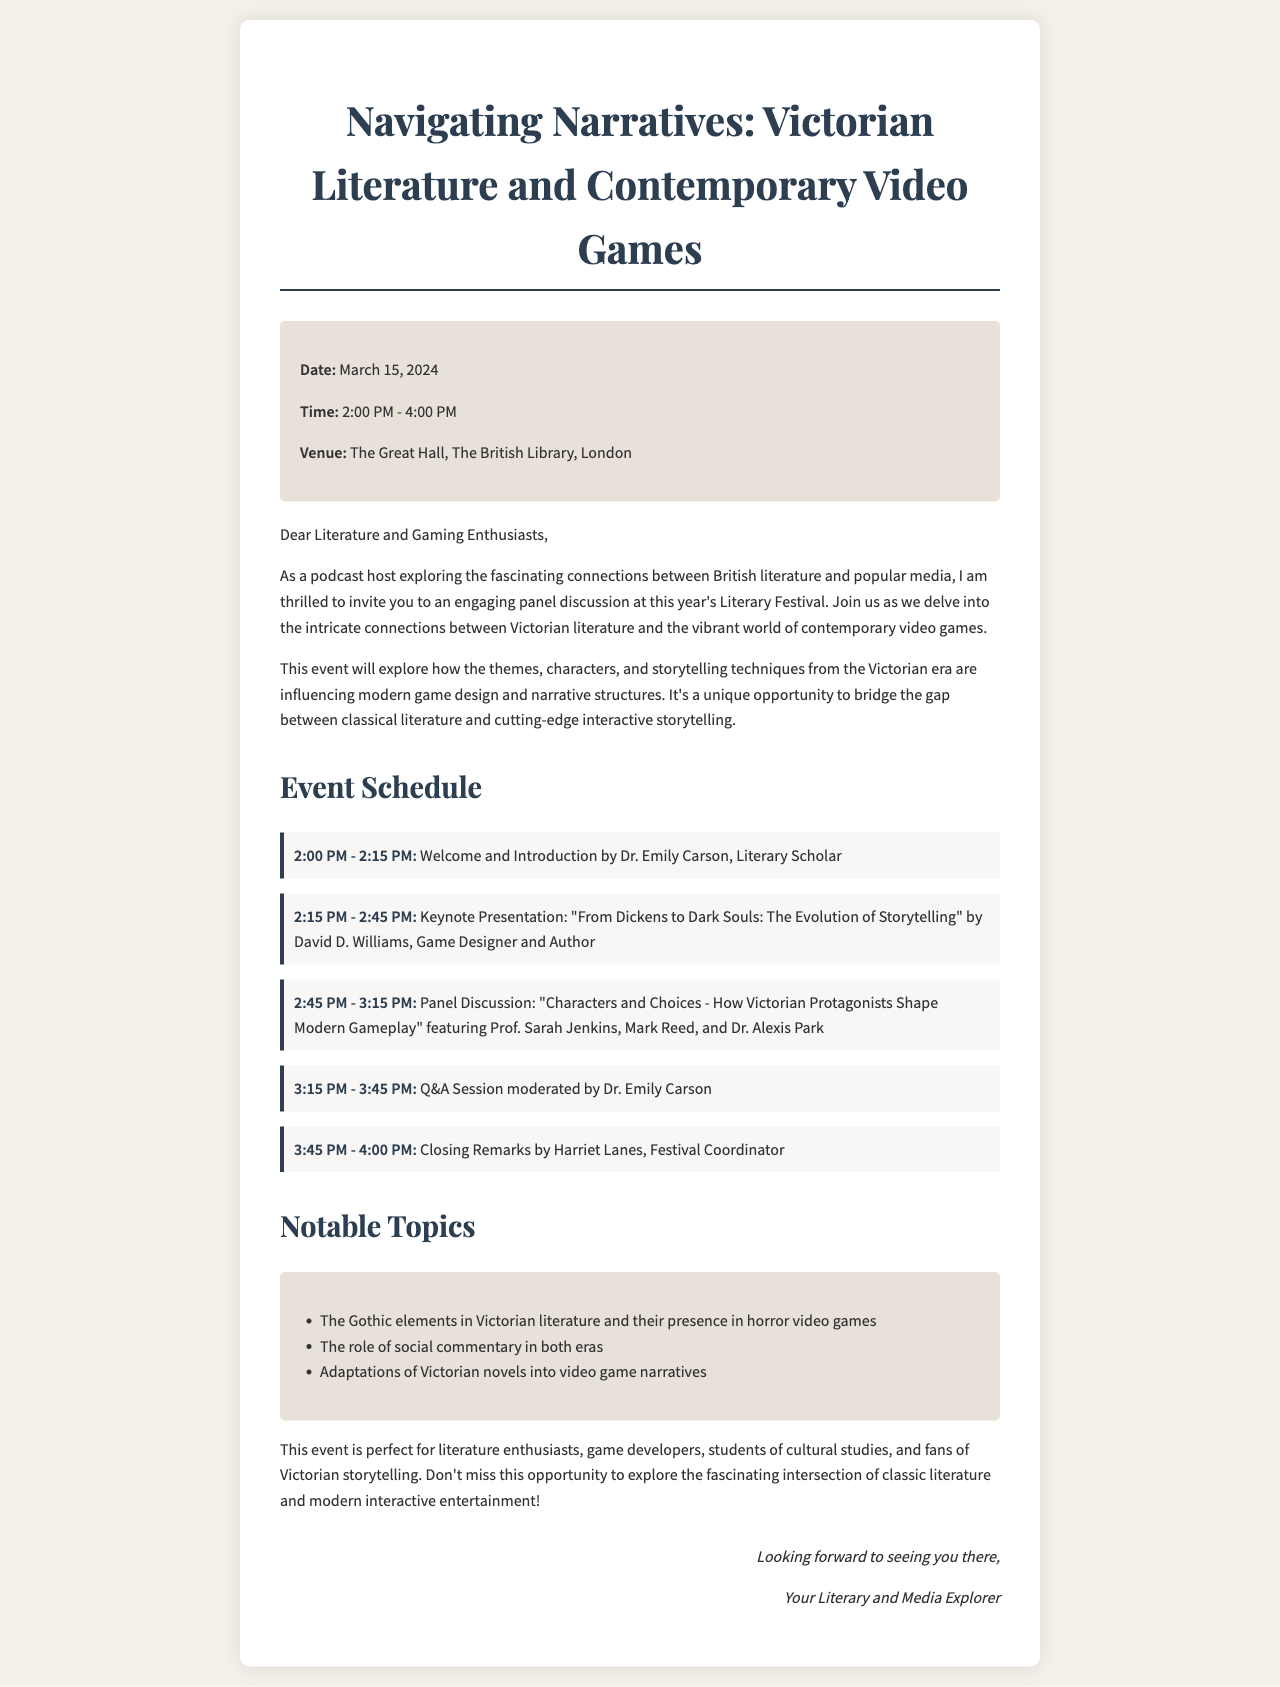what is the event date? The event date is specified in the document under the event details section.
Answer: March 15, 2024 what time does the panel discussion start? The start time of the panel discussion can be found in the event schedule.
Answer: 2:45 PM who is the keynote speaker for the presentation? The identity of the keynote speaker is mentioned in the event schedule.
Answer: David D. Williams how long is the Q&A session? The duration of the Q&A session can be calculated from the schedule.
Answer: 30 minutes what is the title of the keynote presentation? The title of the keynote presentation is directly stated in the event schedule.
Answer: From Dickens to Dark Souls: The Evolution of Storytelling who will moderate the Q&A session? The moderator of the Q&A session is mentioned in the schedule.
Answer: Dr. Emily Carson which venue is hosting the event? The hosting venue is specified under the event details section in the document.
Answer: The Great Hall, The British Library, London what notable topic is related to horror video games? The notable topics are listed, and one pertains to horror video games.
Answer: The Gothic elements in Victorian literature and their presence in horror video games what is the purpose of this event? The purpose of the event is described in the introductory paragraphs.
Answer: To explore the connections between Victorian literature and contemporary video games 